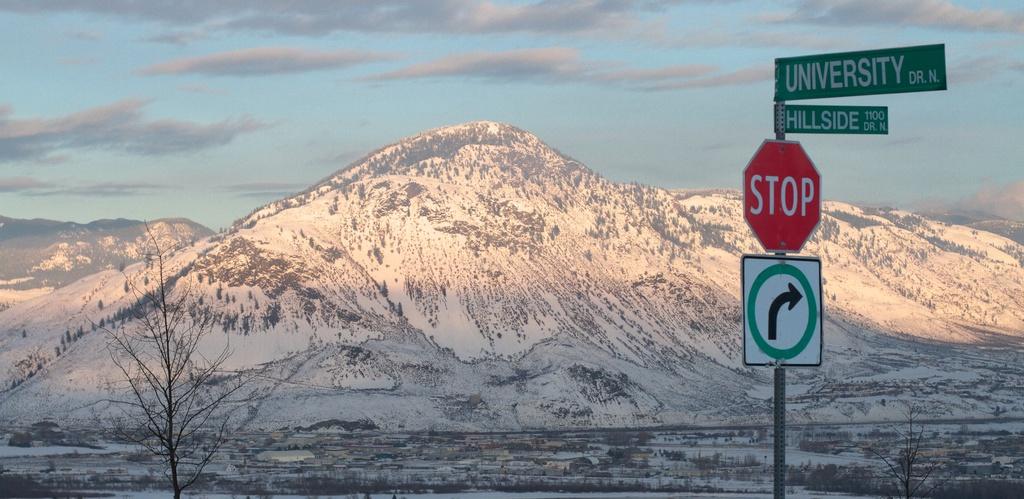What two streets are shown here?
Provide a short and direct response. University, hillside. What are you supposed to do?
Your answer should be very brief. Stop. 